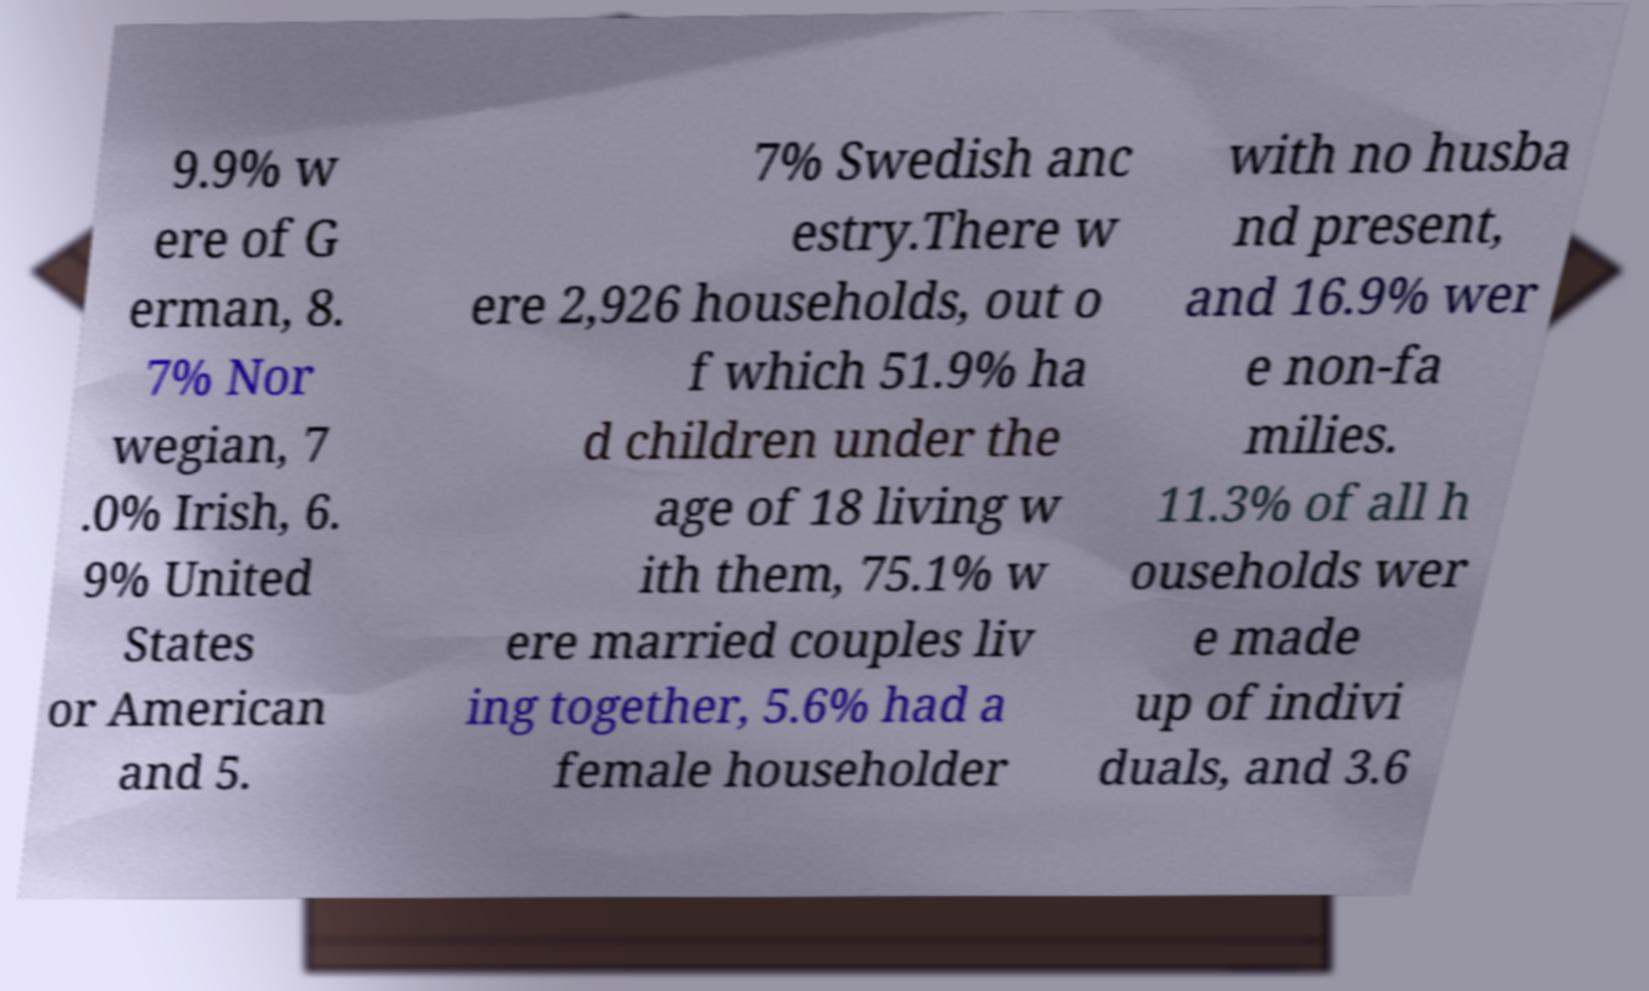I need the written content from this picture converted into text. Can you do that? 9.9% w ere of G erman, 8. 7% Nor wegian, 7 .0% Irish, 6. 9% United States or American and 5. 7% Swedish anc estry.There w ere 2,926 households, out o f which 51.9% ha d children under the age of 18 living w ith them, 75.1% w ere married couples liv ing together, 5.6% had a female householder with no husba nd present, and 16.9% wer e non-fa milies. 11.3% of all h ouseholds wer e made up of indivi duals, and 3.6 